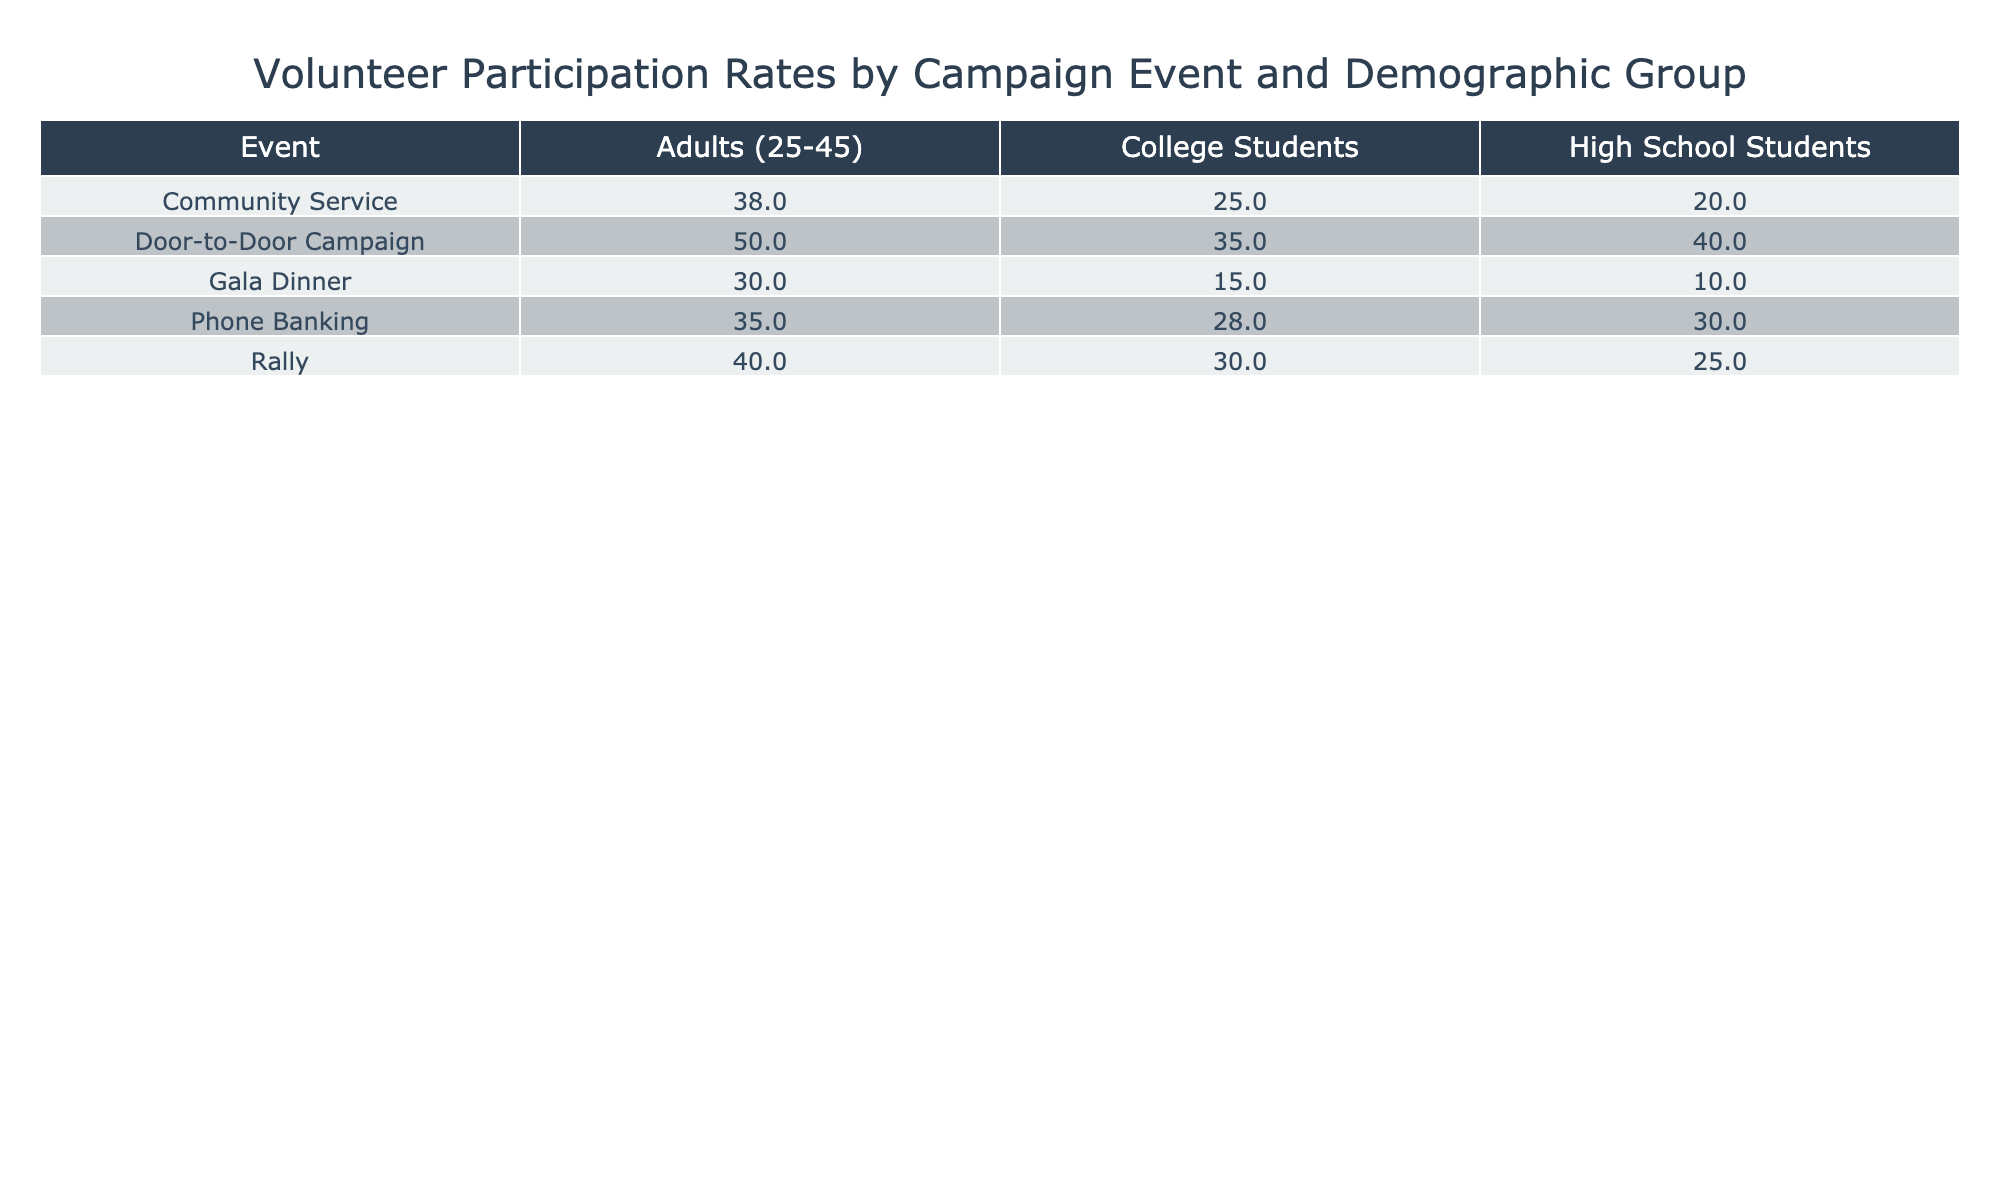What is the participation rate of High School Students at the Rally? The table shows that the participation rate of High School Students for the Rally is directly listed as 25%.
Answer: 25% Which demographic group had the highest participation rate at the Door-to-Door Campaign? The table indicates that Adults (25-45) had the highest participation rate at 50% for the Door-to-Door Campaign.
Answer: Adults (25-45) What is the total participation rate for College Students across all events? To find the total participation rate for College Students, we sum the participation rates: 30% (Rally) + 15% (Gala Dinner) + 35% (Door-to-Door Campaign) + 28% (Phone Banking) + 25% (Community Service) = 133%.
Answer: 133% Did adults (ages 25-45) perform better than High School Students in all campaign events? By comparing the participation rates for each event, we see that Adults (25-45) had higher rates than High School Students in every event listed, thus confirming that they performed better in all.
Answer: Yes What is the difference in participation rates between High School Students and Adults (25-45) at the Gala Dinner? The participation rate for Adults (25-45) at the Gala Dinner is 30%, and for High School Students, it is 10%. The difference is calculated as 30% - 10% = 20%.
Answer: 20% What is the average participation rate of College Students across all events? To find the average, we add the participation rates of College Students: 30% + 15% + 35% + 28% + 25% = 133%, then divide by the number of events, which is 5, yielding an average of 133% / 5 = 26.6%.
Answer: 26.6% How does the participation rate of High School Students compare to that of College Students at the Phone Banking event? High School Students have a participation rate of 30%, while College Students have a rate of 28%. High School Students have a higher participation rate by 2%.
Answer: High School Students are higher by 2% What is the total number of volunteers from Adults (25-45) for all campaign events? By adding the volunteer counts for Adults (25-45) from all events: 200 (Rally) + 150 (Gala Dinner) + 250 (Door-to-Door Campaign) + 170 (Phone Banking) + 180 (Community Service) = 950 volunteers.
Answer: 950 volunteers Which campaign event has the lowest overall participation rate among High School Students? Upon reviewing the table, the Gala Dinner is listed as having the lowest participation rate for High School Students at 10%.
Answer: Gala Dinner Is it true that the Door-to-Door Campaign had the highest total number of volunteers overall? The total number of volunteers for the Door-to-Door Campaign is 250 (Adults) + 120 (College) + 80 (High School) = 450. Comparing to other events, this is indeed the highest total.
Answer: Yes 